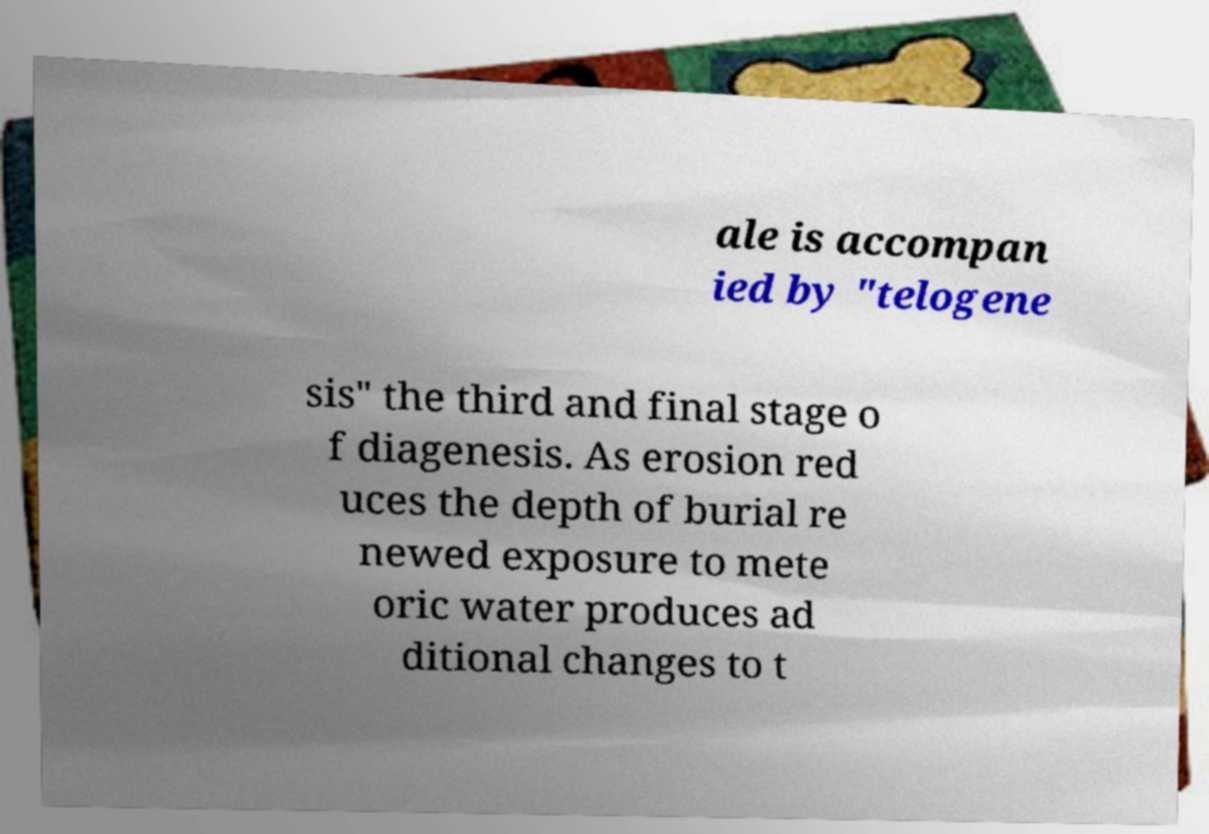Could you extract and type out the text from this image? ale is accompan ied by "telogene sis" the third and final stage o f diagenesis. As erosion red uces the depth of burial re newed exposure to mete oric water produces ad ditional changes to t 